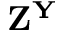Convert formula to latex. <formula><loc_0><loc_0><loc_500><loc_500>Z ^ { Y }</formula> 